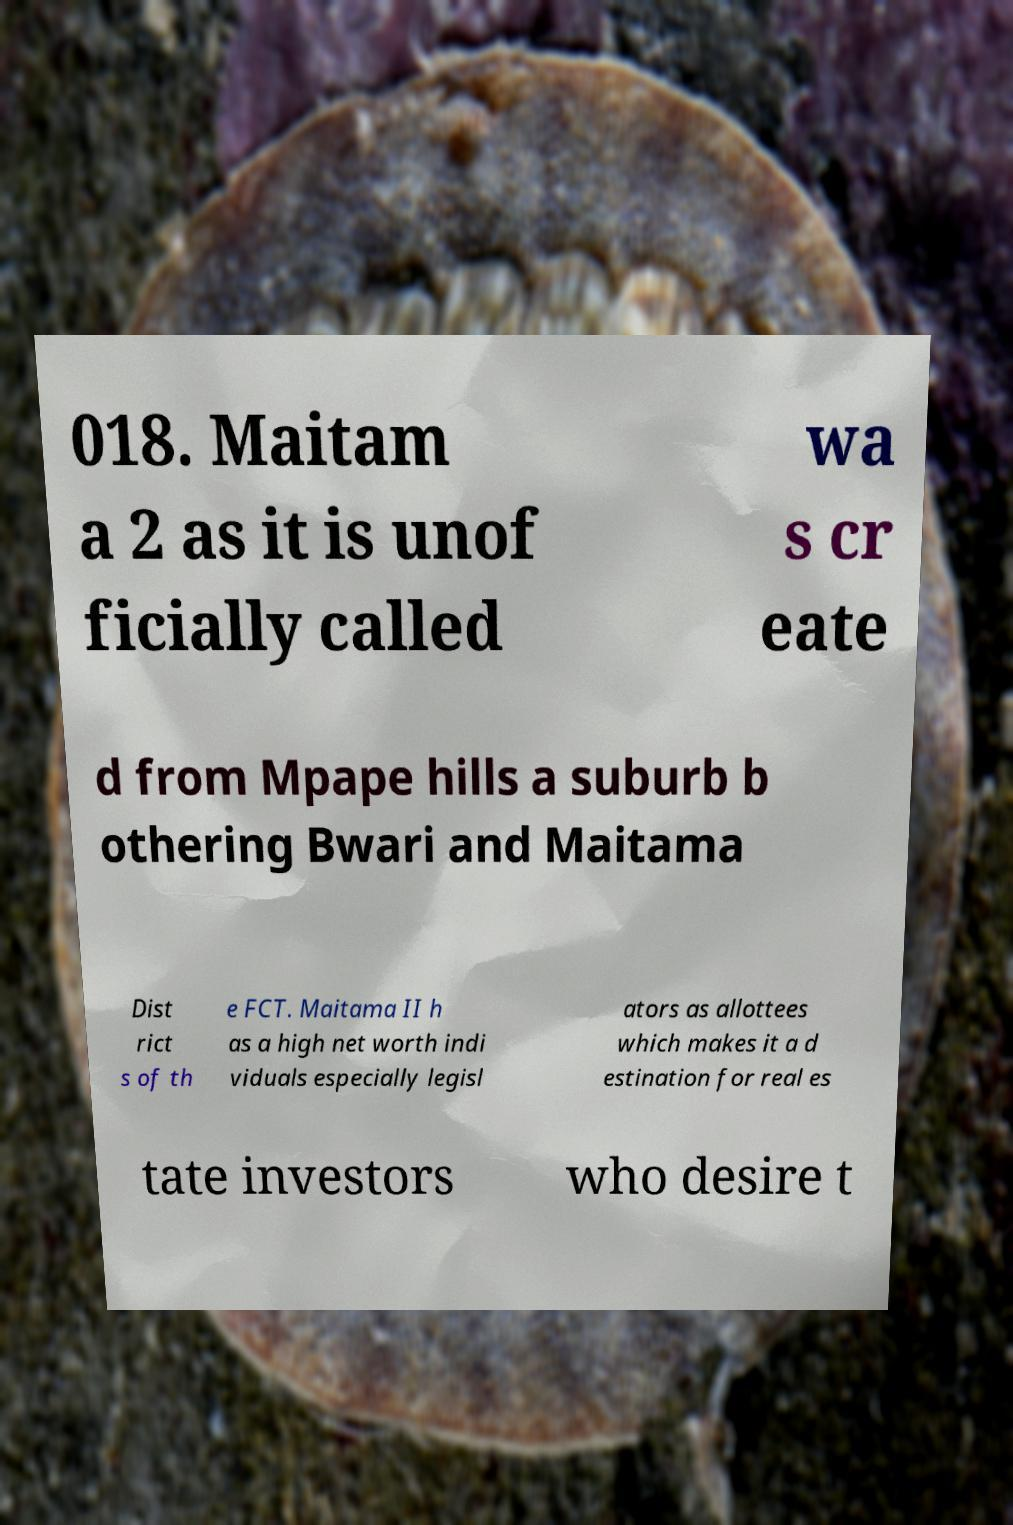There's text embedded in this image that I need extracted. Can you transcribe it verbatim? 018. Maitam a 2 as it is unof ficially called wa s cr eate d from Mpape hills a suburb b othering Bwari and Maitama Dist rict s of th e FCT. Maitama II h as a high net worth indi viduals especially legisl ators as allottees which makes it a d estination for real es tate investors who desire t 